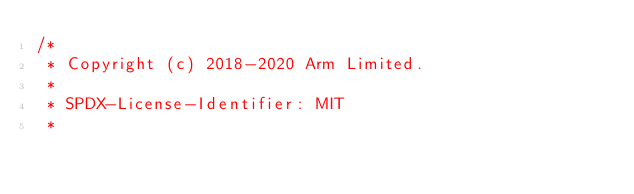Convert code to text. <code><loc_0><loc_0><loc_500><loc_500><_C++_>/*
 * Copyright (c) 2018-2020 Arm Limited.
 *
 * SPDX-License-Identifier: MIT
 *</code> 